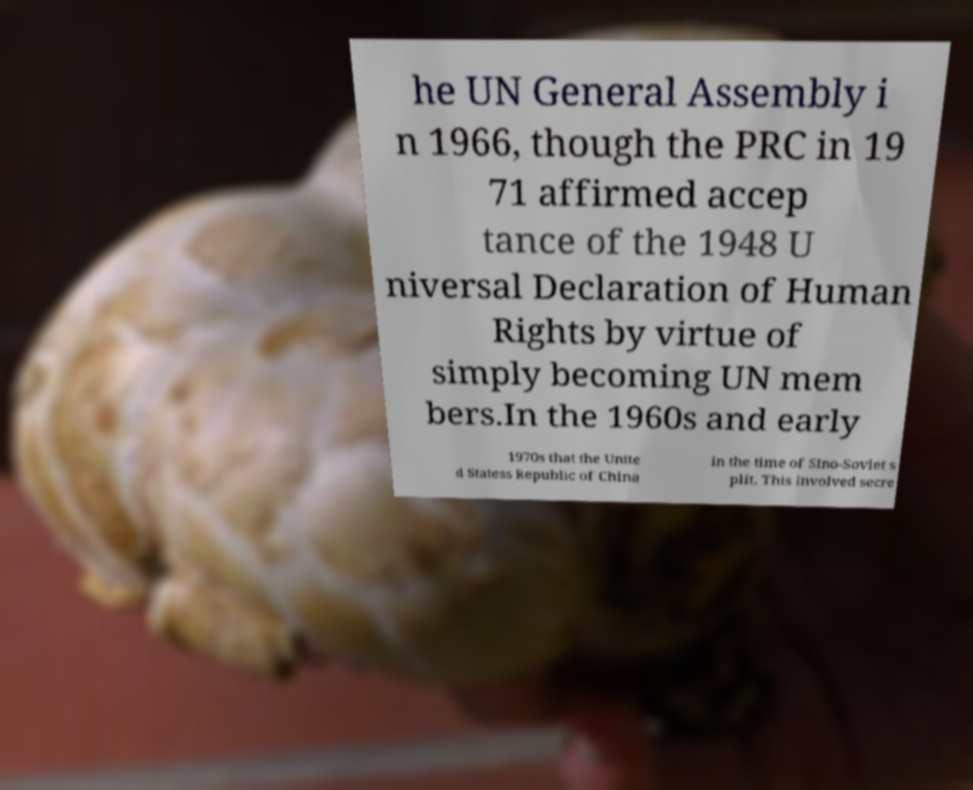Please read and relay the text visible in this image. What does it say? he UN General Assembly i n 1966, though the PRC in 19 71 affirmed accep tance of the 1948 U niversal Declaration of Human Rights by virtue of simply becoming UN mem bers.In the 1960s and early 1970s that the Unite d Statess Republic of China in the time of Sino-Soviet s plit. This involved secre 